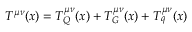Convert formula to latex. <formula><loc_0><loc_0><loc_500><loc_500>T ^ { \mu \nu } ( x ) = T _ { Q } ^ { \mu \nu } ( x ) + T _ { G } ^ { \mu \nu } ( x ) + T _ { q } ^ { \mu \nu } ( x )</formula> 